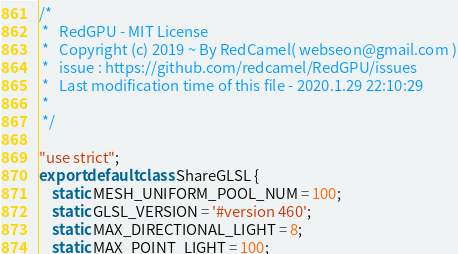<code> <loc_0><loc_0><loc_500><loc_500><_JavaScript_>/*
 *   RedGPU - MIT License
 *   Copyright (c) 2019 ~ By RedCamel( webseon@gmail.com )
 *   issue : https://github.com/redcamel/RedGPU/issues
 *   Last modification time of this file - 2020.1.29 22:10:29
 *
 */

"use strict";
export default class ShareGLSL {
	static MESH_UNIFORM_POOL_NUM = 100;
	static GLSL_VERSION = '#version 460';
	static MAX_DIRECTIONAL_LIGHT = 8;
	static MAX_POINT_LIGHT = 100;</code> 